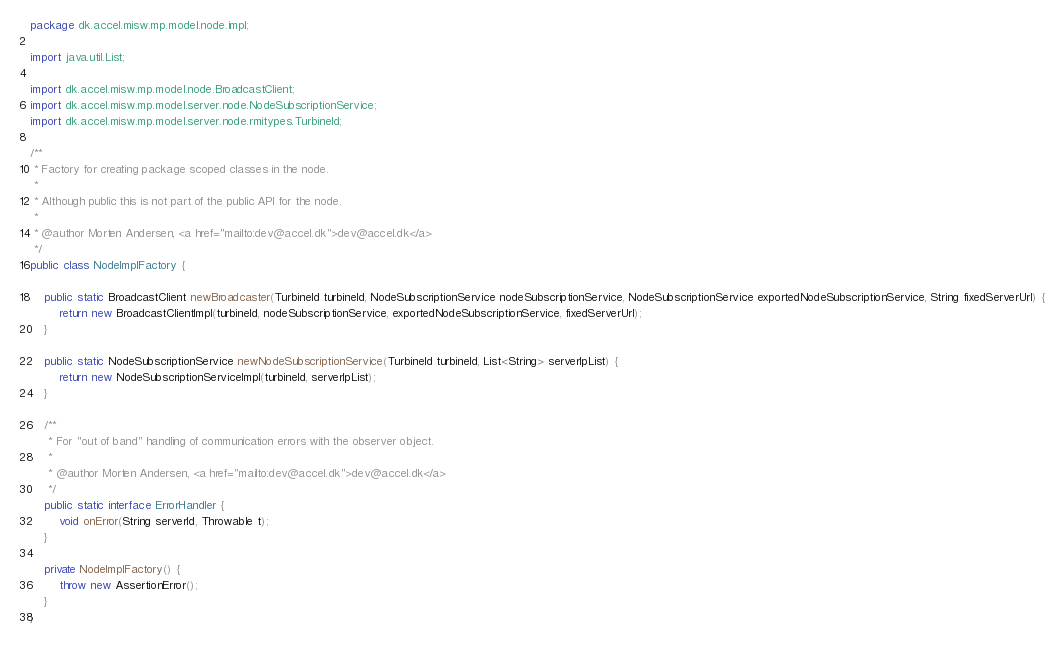<code> <loc_0><loc_0><loc_500><loc_500><_Java_>package dk.accel.misw.mp.model.node.impl;

import java.util.List;

import dk.accel.misw.mp.model.node.BroadcastClient;
import dk.accel.misw.mp.model.server.node.NodeSubscriptionService;
import dk.accel.misw.mp.model.server.node.rmitypes.TurbineId;

/**
 * Factory for creating package scoped classes in the node.
 * 
 * Although public this is not part of the public API for the node.
 * 
 * @author Morten Andersen, <a href="mailto:dev@accel.dk">dev@accel.dk</a>
 */
public class NodeImplFactory {

	public static BroadcastClient newBroadcaster(TurbineId turbineId, NodeSubscriptionService nodeSubscriptionService, NodeSubscriptionService exportedNodeSubscriptionService, String fixedServerUrl) {
		return new BroadcastClientImpl(turbineId, nodeSubscriptionService, exportedNodeSubscriptionService, fixedServerUrl);
	}
	
	public static NodeSubscriptionService newNodeSubscriptionService(TurbineId turbineId, List<String> serverIpList) {
		return new NodeSubscriptionServiceImpl(turbineId, serverIpList);
	}
	
	/**
	 * For "out of band" handling of communication errors with the observer object.
	 * 
	 * @author Morten Andersen, <a href="mailto:dev@accel.dk">dev@accel.dk</a>
	 */
	public static interface ErrorHandler {
		void onError(String serverId, Throwable t);
	}
	
	private NodeImplFactory() {
		throw new AssertionError();
	}
}
</code> 